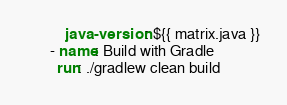<code> <loc_0><loc_0><loc_500><loc_500><_YAML_>          java-version: ${{ matrix.java }}
      - name: Build with Gradle
        run: ./gradlew clean build
</code> 